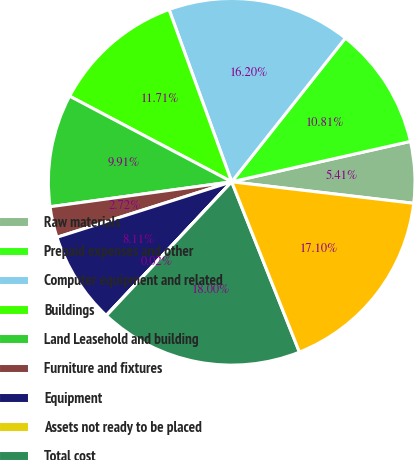<chart> <loc_0><loc_0><loc_500><loc_500><pie_chart><fcel>Raw materials<fcel>Prepaid expenses and other<fcel>Computer equipment and related<fcel>Buildings<fcel>Land Leasehold and building<fcel>Furniture and fixtures<fcel>Equipment<fcel>Assets not ready to be placed<fcel>Total cost<fcel>Less Accumulated depreciation<nl><fcel>5.41%<fcel>10.81%<fcel>16.2%<fcel>11.71%<fcel>9.91%<fcel>2.72%<fcel>8.11%<fcel>0.02%<fcel>18.0%<fcel>17.1%<nl></chart> 